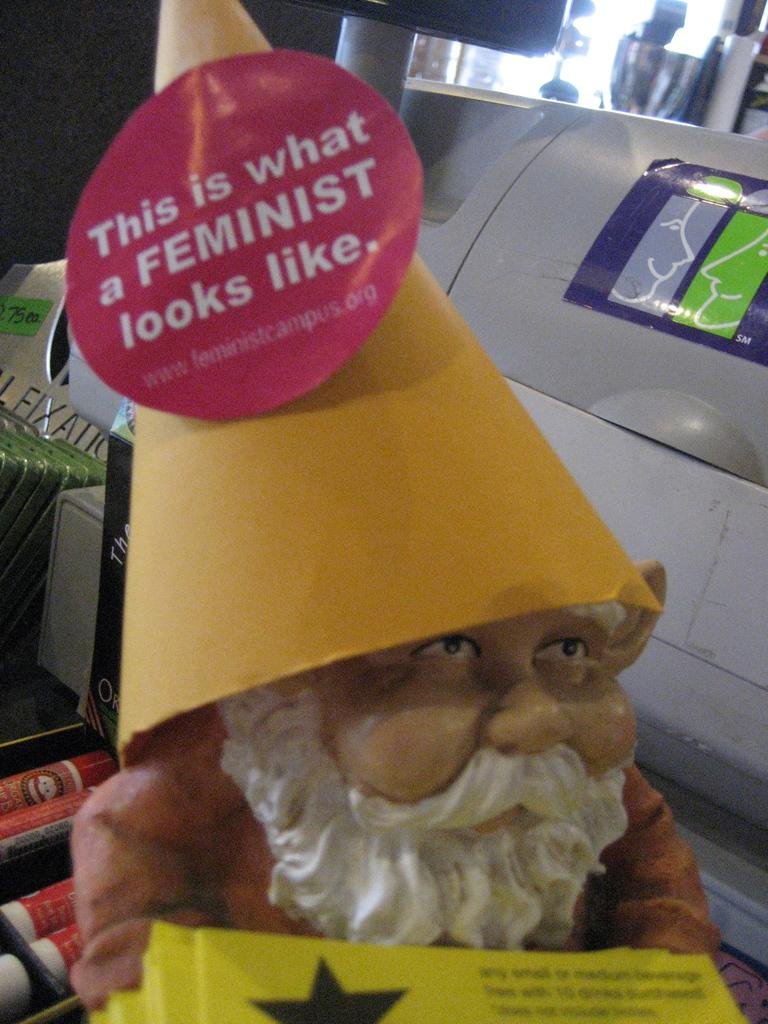What is the main subject in the center of the image? There is a toy in the center of the image. What else can be seen in the image besides the toy? There are objects visible in the background. Can you describe the background of the image? There is a wall in the background. How does the toy increase in size during the holiday season in the image? There is no indication of a holiday season or the toy increasing in size in the image. 